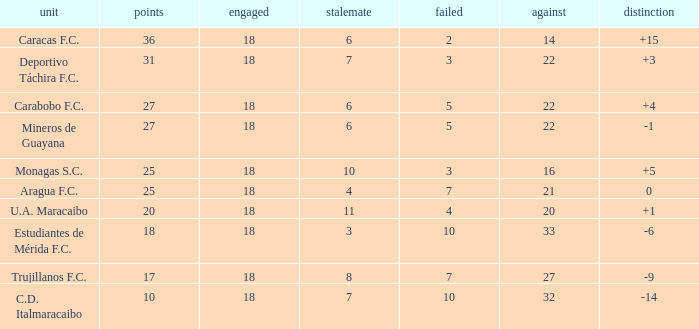What is the average against score of all teams with less than 7 losses, more than 6 draws, and 25 points? 16.0. 